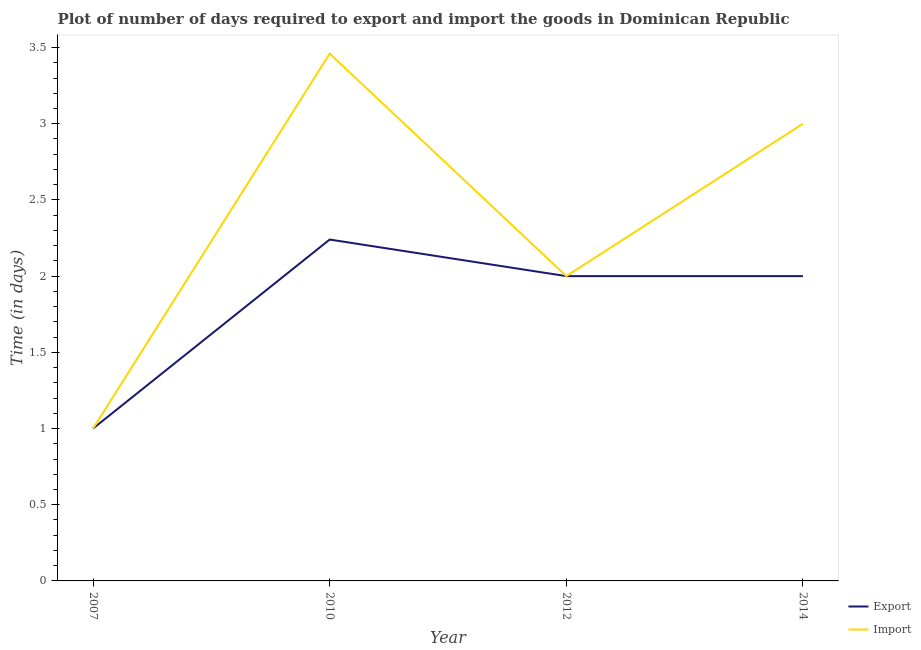How many different coloured lines are there?
Give a very brief answer. 2. Does the line corresponding to time required to import intersect with the line corresponding to time required to export?
Your response must be concise. Yes. Across all years, what is the maximum time required to export?
Provide a short and direct response. 2.24. Across all years, what is the minimum time required to export?
Your answer should be very brief. 1. In which year was the time required to import maximum?
Your response must be concise. 2010. What is the total time required to import in the graph?
Offer a very short reply. 9.46. What is the difference between the time required to export in 2010 and that in 2014?
Provide a short and direct response. 0.24. What is the difference between the time required to export in 2014 and the time required to import in 2007?
Give a very brief answer. 1. What is the average time required to import per year?
Provide a short and direct response. 2.37. In the year 2007, what is the difference between the time required to import and time required to export?
Offer a very short reply. 0. What is the ratio of the time required to export in 2010 to that in 2014?
Provide a succinct answer. 1.12. Is the time required to import in 2007 less than that in 2012?
Offer a terse response. Yes. Is the difference between the time required to import in 2010 and 2012 greater than the difference between the time required to export in 2010 and 2012?
Your answer should be very brief. Yes. What is the difference between the highest and the second highest time required to import?
Your response must be concise. 0.46. What is the difference between the highest and the lowest time required to import?
Give a very brief answer. 2.46. In how many years, is the time required to export greater than the average time required to export taken over all years?
Ensure brevity in your answer.  3. Does the time required to export monotonically increase over the years?
Provide a short and direct response. No. Is the time required to import strictly less than the time required to export over the years?
Offer a very short reply. No. How many lines are there?
Offer a very short reply. 2. Does the graph contain any zero values?
Ensure brevity in your answer.  No. Where does the legend appear in the graph?
Your answer should be very brief. Bottom right. How are the legend labels stacked?
Your answer should be very brief. Vertical. What is the title of the graph?
Your answer should be compact. Plot of number of days required to export and import the goods in Dominican Republic. What is the label or title of the Y-axis?
Your answer should be very brief. Time (in days). What is the Time (in days) in Export in 2007?
Your response must be concise. 1. What is the Time (in days) of Import in 2007?
Offer a terse response. 1. What is the Time (in days) of Export in 2010?
Keep it short and to the point. 2.24. What is the Time (in days) in Import in 2010?
Keep it short and to the point. 3.46. What is the Time (in days) in Export in 2012?
Provide a succinct answer. 2. What is the Time (in days) in Import in 2012?
Your answer should be compact. 2. What is the Time (in days) of Export in 2014?
Provide a short and direct response. 2. Across all years, what is the maximum Time (in days) in Export?
Your answer should be compact. 2.24. Across all years, what is the maximum Time (in days) in Import?
Keep it short and to the point. 3.46. Across all years, what is the minimum Time (in days) in Export?
Offer a terse response. 1. Across all years, what is the minimum Time (in days) in Import?
Offer a terse response. 1. What is the total Time (in days) of Export in the graph?
Ensure brevity in your answer.  7.24. What is the total Time (in days) of Import in the graph?
Offer a very short reply. 9.46. What is the difference between the Time (in days) in Export in 2007 and that in 2010?
Ensure brevity in your answer.  -1.24. What is the difference between the Time (in days) of Import in 2007 and that in 2010?
Ensure brevity in your answer.  -2.46. What is the difference between the Time (in days) of Export in 2007 and that in 2012?
Provide a succinct answer. -1. What is the difference between the Time (in days) of Import in 2007 and that in 2012?
Keep it short and to the point. -1. What is the difference between the Time (in days) of Import in 2007 and that in 2014?
Your response must be concise. -2. What is the difference between the Time (in days) of Export in 2010 and that in 2012?
Make the answer very short. 0.24. What is the difference between the Time (in days) of Import in 2010 and that in 2012?
Give a very brief answer. 1.46. What is the difference between the Time (in days) in Export in 2010 and that in 2014?
Your response must be concise. 0.24. What is the difference between the Time (in days) in Import in 2010 and that in 2014?
Provide a succinct answer. 0.46. What is the difference between the Time (in days) of Export in 2007 and the Time (in days) of Import in 2010?
Your response must be concise. -2.46. What is the difference between the Time (in days) of Export in 2010 and the Time (in days) of Import in 2012?
Your answer should be compact. 0.24. What is the difference between the Time (in days) of Export in 2010 and the Time (in days) of Import in 2014?
Provide a succinct answer. -0.76. What is the average Time (in days) in Export per year?
Provide a succinct answer. 1.81. What is the average Time (in days) of Import per year?
Your answer should be very brief. 2.37. In the year 2007, what is the difference between the Time (in days) of Export and Time (in days) of Import?
Keep it short and to the point. 0. In the year 2010, what is the difference between the Time (in days) of Export and Time (in days) of Import?
Offer a terse response. -1.22. In the year 2012, what is the difference between the Time (in days) in Export and Time (in days) in Import?
Your answer should be compact. 0. What is the ratio of the Time (in days) in Export in 2007 to that in 2010?
Provide a succinct answer. 0.45. What is the ratio of the Time (in days) of Import in 2007 to that in 2010?
Make the answer very short. 0.29. What is the ratio of the Time (in days) in Export in 2007 to that in 2012?
Give a very brief answer. 0.5. What is the ratio of the Time (in days) in Export in 2007 to that in 2014?
Make the answer very short. 0.5. What is the ratio of the Time (in days) of Import in 2007 to that in 2014?
Your answer should be compact. 0.33. What is the ratio of the Time (in days) of Export in 2010 to that in 2012?
Your answer should be very brief. 1.12. What is the ratio of the Time (in days) of Import in 2010 to that in 2012?
Give a very brief answer. 1.73. What is the ratio of the Time (in days) in Export in 2010 to that in 2014?
Offer a very short reply. 1.12. What is the ratio of the Time (in days) of Import in 2010 to that in 2014?
Provide a short and direct response. 1.15. What is the ratio of the Time (in days) of Import in 2012 to that in 2014?
Provide a short and direct response. 0.67. What is the difference between the highest and the second highest Time (in days) of Export?
Your answer should be compact. 0.24. What is the difference between the highest and the second highest Time (in days) of Import?
Your answer should be compact. 0.46. What is the difference between the highest and the lowest Time (in days) in Export?
Offer a terse response. 1.24. What is the difference between the highest and the lowest Time (in days) in Import?
Provide a short and direct response. 2.46. 